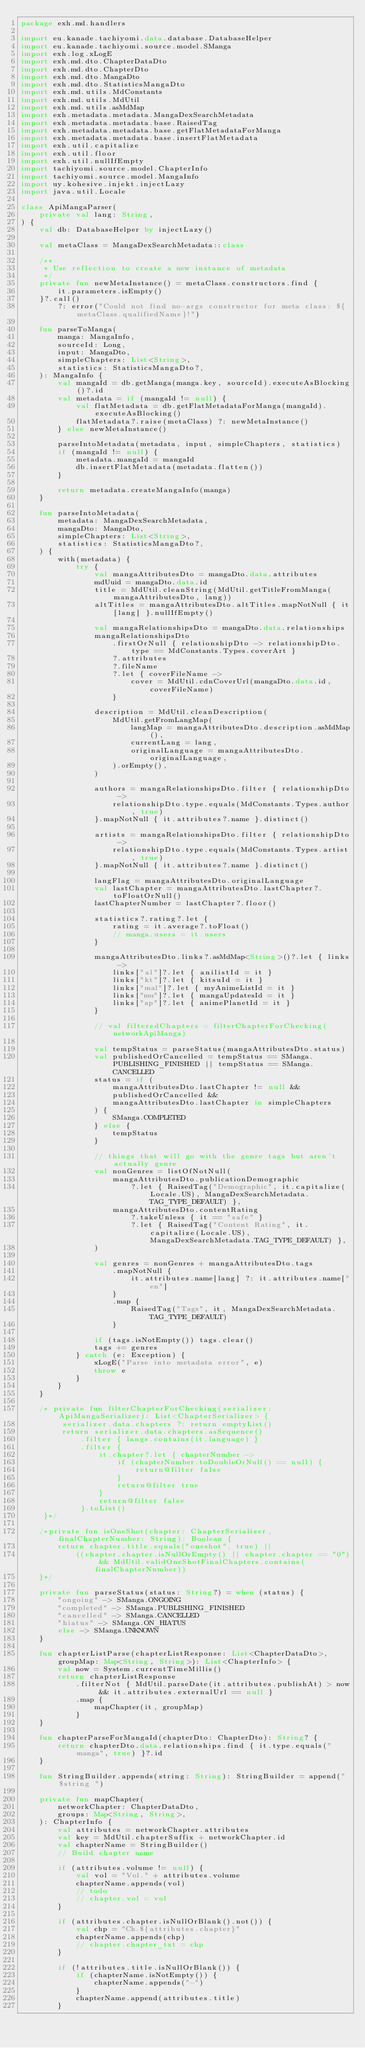Convert code to text. <code><loc_0><loc_0><loc_500><loc_500><_Kotlin_>package exh.md.handlers

import eu.kanade.tachiyomi.data.database.DatabaseHelper
import eu.kanade.tachiyomi.source.model.SManga
import exh.log.xLogE
import exh.md.dto.ChapterDataDto
import exh.md.dto.ChapterDto
import exh.md.dto.MangaDto
import exh.md.dto.StatisticsMangaDto
import exh.md.utils.MdConstants
import exh.md.utils.MdUtil
import exh.md.utils.asMdMap
import exh.metadata.metadata.MangaDexSearchMetadata
import exh.metadata.metadata.base.RaisedTag
import exh.metadata.metadata.base.getFlatMetadataForManga
import exh.metadata.metadata.base.insertFlatMetadata
import exh.util.capitalize
import exh.util.floor
import exh.util.nullIfEmpty
import tachiyomi.source.model.ChapterInfo
import tachiyomi.source.model.MangaInfo
import uy.kohesive.injekt.injectLazy
import java.util.Locale

class ApiMangaParser(
    private val lang: String,
) {
    val db: DatabaseHelper by injectLazy()

    val metaClass = MangaDexSearchMetadata::class

    /**
     * Use reflection to create a new instance of metadata
     */
    private fun newMetaInstance() = metaClass.constructors.find {
        it.parameters.isEmpty()
    }?.call()
        ?: error("Could not find no-args constructor for meta class: ${metaClass.qualifiedName}!")

    fun parseToManga(
        manga: MangaInfo,
        sourceId: Long,
        input: MangaDto,
        simpleChapters: List<String>,
        statistics: StatisticsMangaDto?,
    ): MangaInfo {
        val mangaId = db.getManga(manga.key, sourceId).executeAsBlocking()?.id
        val metadata = if (mangaId != null) {
            val flatMetadata = db.getFlatMetadataForManga(mangaId).executeAsBlocking()
            flatMetadata?.raise(metaClass) ?: newMetaInstance()
        } else newMetaInstance()

        parseIntoMetadata(metadata, input, simpleChapters, statistics)
        if (mangaId != null) {
            metadata.mangaId = mangaId
            db.insertFlatMetadata(metadata.flatten())
        }

        return metadata.createMangaInfo(manga)
    }

    fun parseIntoMetadata(
        metadata: MangaDexSearchMetadata,
        mangaDto: MangaDto,
        simpleChapters: List<String>,
        statistics: StatisticsMangaDto?,
    ) {
        with(metadata) {
            try {
                val mangaAttributesDto = mangaDto.data.attributes
                mdUuid = mangaDto.data.id
                title = MdUtil.cleanString(MdUtil.getTitleFromManga(mangaAttributesDto, lang))
                altTitles = mangaAttributesDto.altTitles.mapNotNull { it[lang] }.nullIfEmpty()

                val mangaRelationshipsDto = mangaDto.data.relationships
                mangaRelationshipsDto
                    .firstOrNull { relationshipDto -> relationshipDto.type == MdConstants.Types.coverArt }
                    ?.attributes
                    ?.fileName
                    ?.let { coverFileName ->
                        cover = MdUtil.cdnCoverUrl(mangaDto.data.id, coverFileName)
                    }

                description = MdUtil.cleanDescription(
                    MdUtil.getFromLangMap(
                        langMap = mangaAttributesDto.description.asMdMap(),
                        currentLang = lang,
                        originalLanguage = mangaAttributesDto.originalLanguage,
                    ).orEmpty(),
                )

                authors = mangaRelationshipsDto.filter { relationshipDto ->
                    relationshipDto.type.equals(MdConstants.Types.author, true)
                }.mapNotNull { it.attributes?.name }.distinct()

                artists = mangaRelationshipsDto.filter { relationshipDto ->
                    relationshipDto.type.equals(MdConstants.Types.artist, true)
                }.mapNotNull { it.attributes?.name }.distinct()

                langFlag = mangaAttributesDto.originalLanguage
                val lastChapter = mangaAttributesDto.lastChapter?.toFloatOrNull()
                lastChapterNumber = lastChapter?.floor()

                statistics?.rating?.let {
                    rating = it.average?.toFloat()
                    // manga.users = it.users
                }

                mangaAttributesDto.links?.asMdMap<String>()?.let { links ->
                    links["al"]?.let { anilistId = it }
                    links["kt"]?.let { kitsuId = it }
                    links["mal"]?.let { myAnimeListId = it }
                    links["mu"]?.let { mangaUpdatesId = it }
                    links["ap"]?.let { animePlanetId = it }
                }

                // val filteredChapters = filterChapterForChecking(networkApiManga)

                val tempStatus = parseStatus(mangaAttributesDto.status)
                val publishedOrCancelled = tempStatus == SManga.PUBLISHING_FINISHED || tempStatus == SManga.CANCELLED
                status = if (
                    mangaAttributesDto.lastChapter != null &&
                    publishedOrCancelled &&
                    mangaAttributesDto.lastChapter in simpleChapters
                ) {
                    SManga.COMPLETED
                } else {
                    tempStatus
                }

                // things that will go with the genre tags but aren't actually genre
                val nonGenres = listOfNotNull(
                    mangaAttributesDto.publicationDemographic
                        ?.let { RaisedTag("Demographic", it.capitalize(Locale.US), MangaDexSearchMetadata.TAG_TYPE_DEFAULT) },
                    mangaAttributesDto.contentRating
                        ?.takeUnless { it == "safe" }
                        ?.let { RaisedTag("Content Rating", it.capitalize(Locale.US), MangaDexSearchMetadata.TAG_TYPE_DEFAULT) },
                )

                val genres = nonGenres + mangaAttributesDto.tags
                    .mapNotNull {
                        it.attributes.name[lang] ?: it.attributes.name["en"]
                    }
                    .map {
                        RaisedTag("Tags", it, MangaDexSearchMetadata.TAG_TYPE_DEFAULT)
                    }

                if (tags.isNotEmpty()) tags.clear()
                tags += genres
            } catch (e: Exception) {
                xLogE("Parse into metadata error", e)
                throw e
            }
        }
    }

    /* private fun filterChapterForChecking(serializer: ApiMangaSerializer): List<ChapterSerializer> {
         serializer.data.chapters ?: return emptyList()
         return serializer.data.chapters.asSequence()
             .filter { langs.contains(it.language) }
             .filter {
                 it.chapter?.let { chapterNumber ->
                     if (chapterNumber.toDoubleOrNull() == null) {
                         return@filter false
                     }
                     return@filter true
                 }
                 return@filter false
             }.toList()
     }*/

    /*private fun isOneShot(chapter: ChapterSerializer, finalChapterNumber: String): Boolean {
        return chapter.title.equals("oneshot", true) ||
            ((chapter.chapter.isNullOrEmpty() || chapter.chapter == "0") && MdUtil.validOneShotFinalChapters.contains(finalChapterNumber))
    }*/

    private fun parseStatus(status: String?) = when (status) {
        "ongoing" -> SManga.ONGOING
        "completed" -> SManga.PUBLISHING_FINISHED
        "cancelled" -> SManga.CANCELLED
        "hiatus" -> SManga.ON_HIATUS
        else -> SManga.UNKNOWN
    }

    fun chapterListParse(chapterListResponse: List<ChapterDataDto>, groupMap: Map<String, String>): List<ChapterInfo> {
        val now = System.currentTimeMillis()
        return chapterListResponse
            .filterNot { MdUtil.parseDate(it.attributes.publishAt) > now && it.attributes.externalUrl == null }
            .map {
                mapChapter(it, groupMap)
            }
    }

    fun chapterParseForMangaId(chapterDto: ChapterDto): String? {
        return chapterDto.data.relationships.find { it.type.equals("manga", true) }?.id
    }

    fun StringBuilder.appends(string: String): StringBuilder = append("$string ")

    private fun mapChapter(
        networkChapter: ChapterDataDto,
        groups: Map<String, String>,
    ): ChapterInfo {
        val attributes = networkChapter.attributes
        val key = MdUtil.chapterSuffix + networkChapter.id
        val chapterName = StringBuilder()
        // Build chapter name

        if (attributes.volume != null) {
            val vol = "Vol." + attributes.volume
            chapterName.appends(vol)
            // todo
            // chapter.vol = vol
        }

        if (attributes.chapter.isNullOrBlank().not()) {
            val chp = "Ch.${attributes.chapter}"
            chapterName.appends(chp)
            // chapter.chapter_txt = chp
        }

        if (!attributes.title.isNullOrBlank()) {
            if (chapterName.isNotEmpty()) {
                chapterName.appends("-")
            }
            chapterName.append(attributes.title)
        }
</code> 